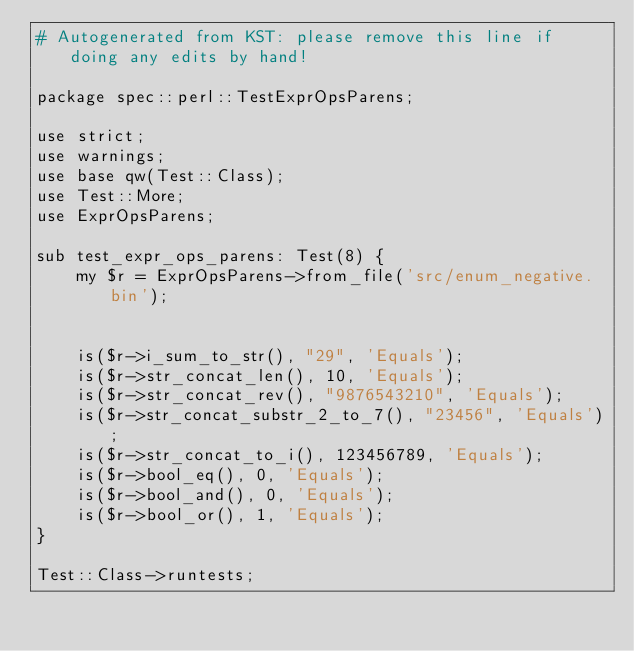Convert code to text. <code><loc_0><loc_0><loc_500><loc_500><_Perl_># Autogenerated from KST: please remove this line if doing any edits by hand!

package spec::perl::TestExprOpsParens;

use strict;
use warnings;
use base qw(Test::Class);
use Test::More;
use ExprOpsParens;

sub test_expr_ops_parens: Test(8) {
    my $r = ExprOpsParens->from_file('src/enum_negative.bin');


    is($r->i_sum_to_str(), "29", 'Equals');
    is($r->str_concat_len(), 10, 'Equals');
    is($r->str_concat_rev(), "9876543210", 'Equals');
    is($r->str_concat_substr_2_to_7(), "23456", 'Equals');
    is($r->str_concat_to_i(), 123456789, 'Equals');
    is($r->bool_eq(), 0, 'Equals');
    is($r->bool_and(), 0, 'Equals');
    is($r->bool_or(), 1, 'Equals');
}

Test::Class->runtests;
</code> 